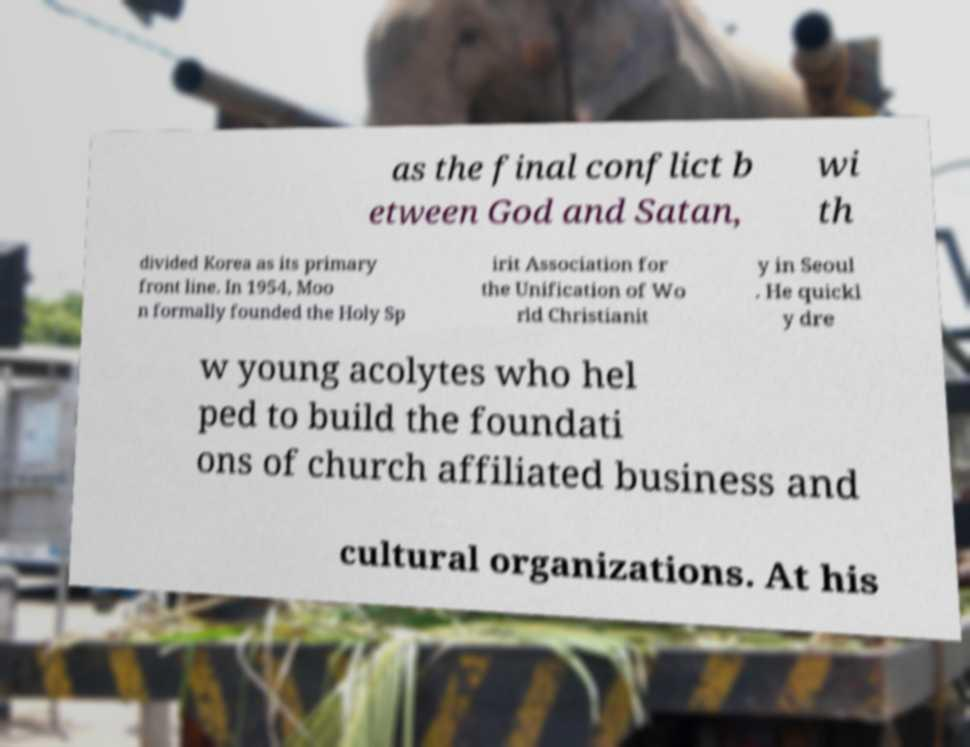I need the written content from this picture converted into text. Can you do that? as the final conflict b etween God and Satan, wi th divided Korea as its primary front line. In 1954, Moo n formally founded the Holy Sp irit Association for the Unification of Wo rld Christianit y in Seoul . He quickl y dre w young acolytes who hel ped to build the foundati ons of church affiliated business and cultural organizations. At his 